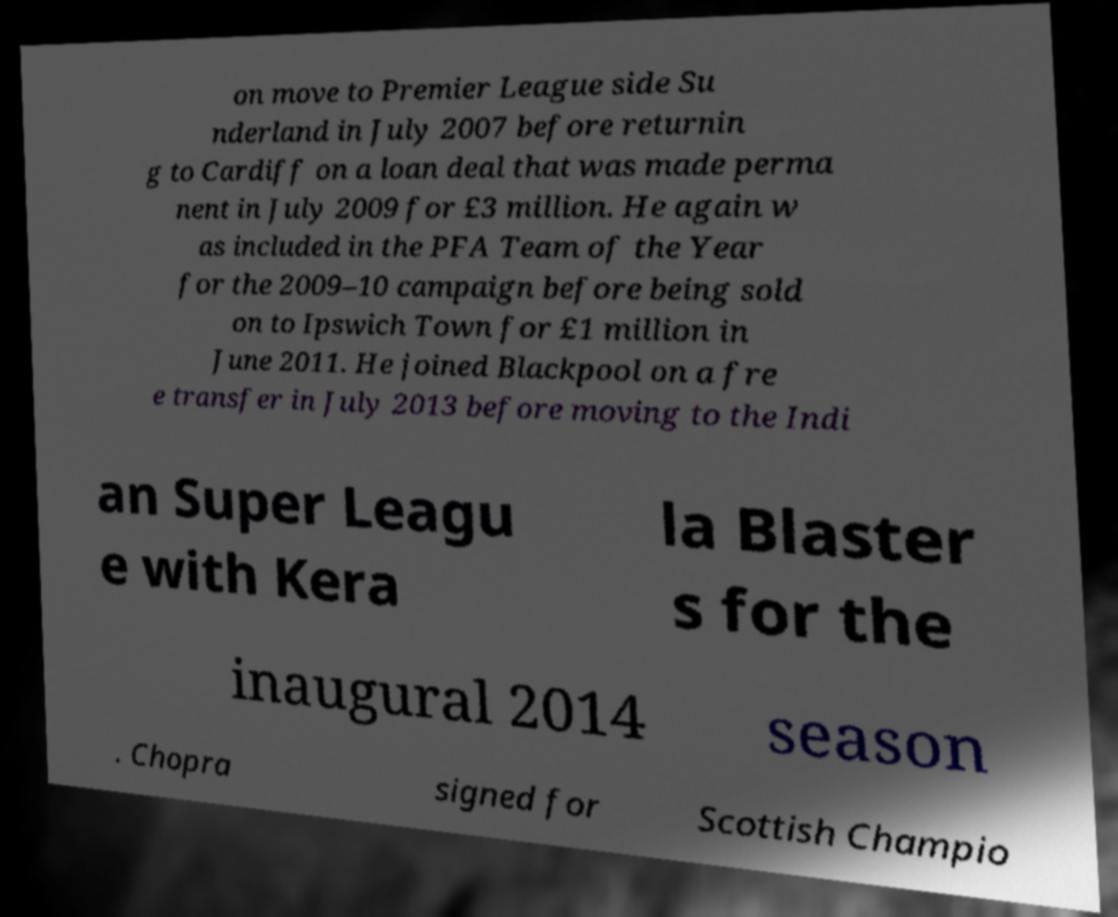Please read and relay the text visible in this image. What does it say? on move to Premier League side Su nderland in July 2007 before returnin g to Cardiff on a loan deal that was made perma nent in July 2009 for £3 million. He again w as included in the PFA Team of the Year for the 2009–10 campaign before being sold on to Ipswich Town for £1 million in June 2011. He joined Blackpool on a fre e transfer in July 2013 before moving to the Indi an Super Leagu e with Kera la Blaster s for the inaugural 2014 season . Chopra signed for Scottish Champio 